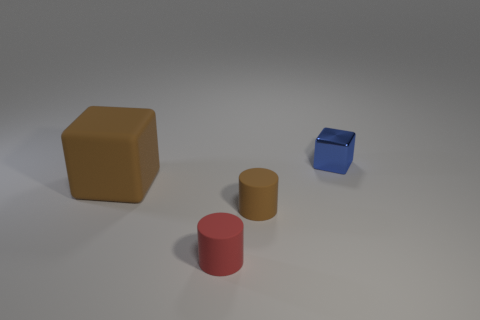Add 4 small matte cylinders. How many objects exist? 8 Subtract 0 purple cylinders. How many objects are left? 4 Subtract all brown objects. Subtract all cubes. How many objects are left? 0 Add 3 small blocks. How many small blocks are left? 4 Add 4 cylinders. How many cylinders exist? 6 